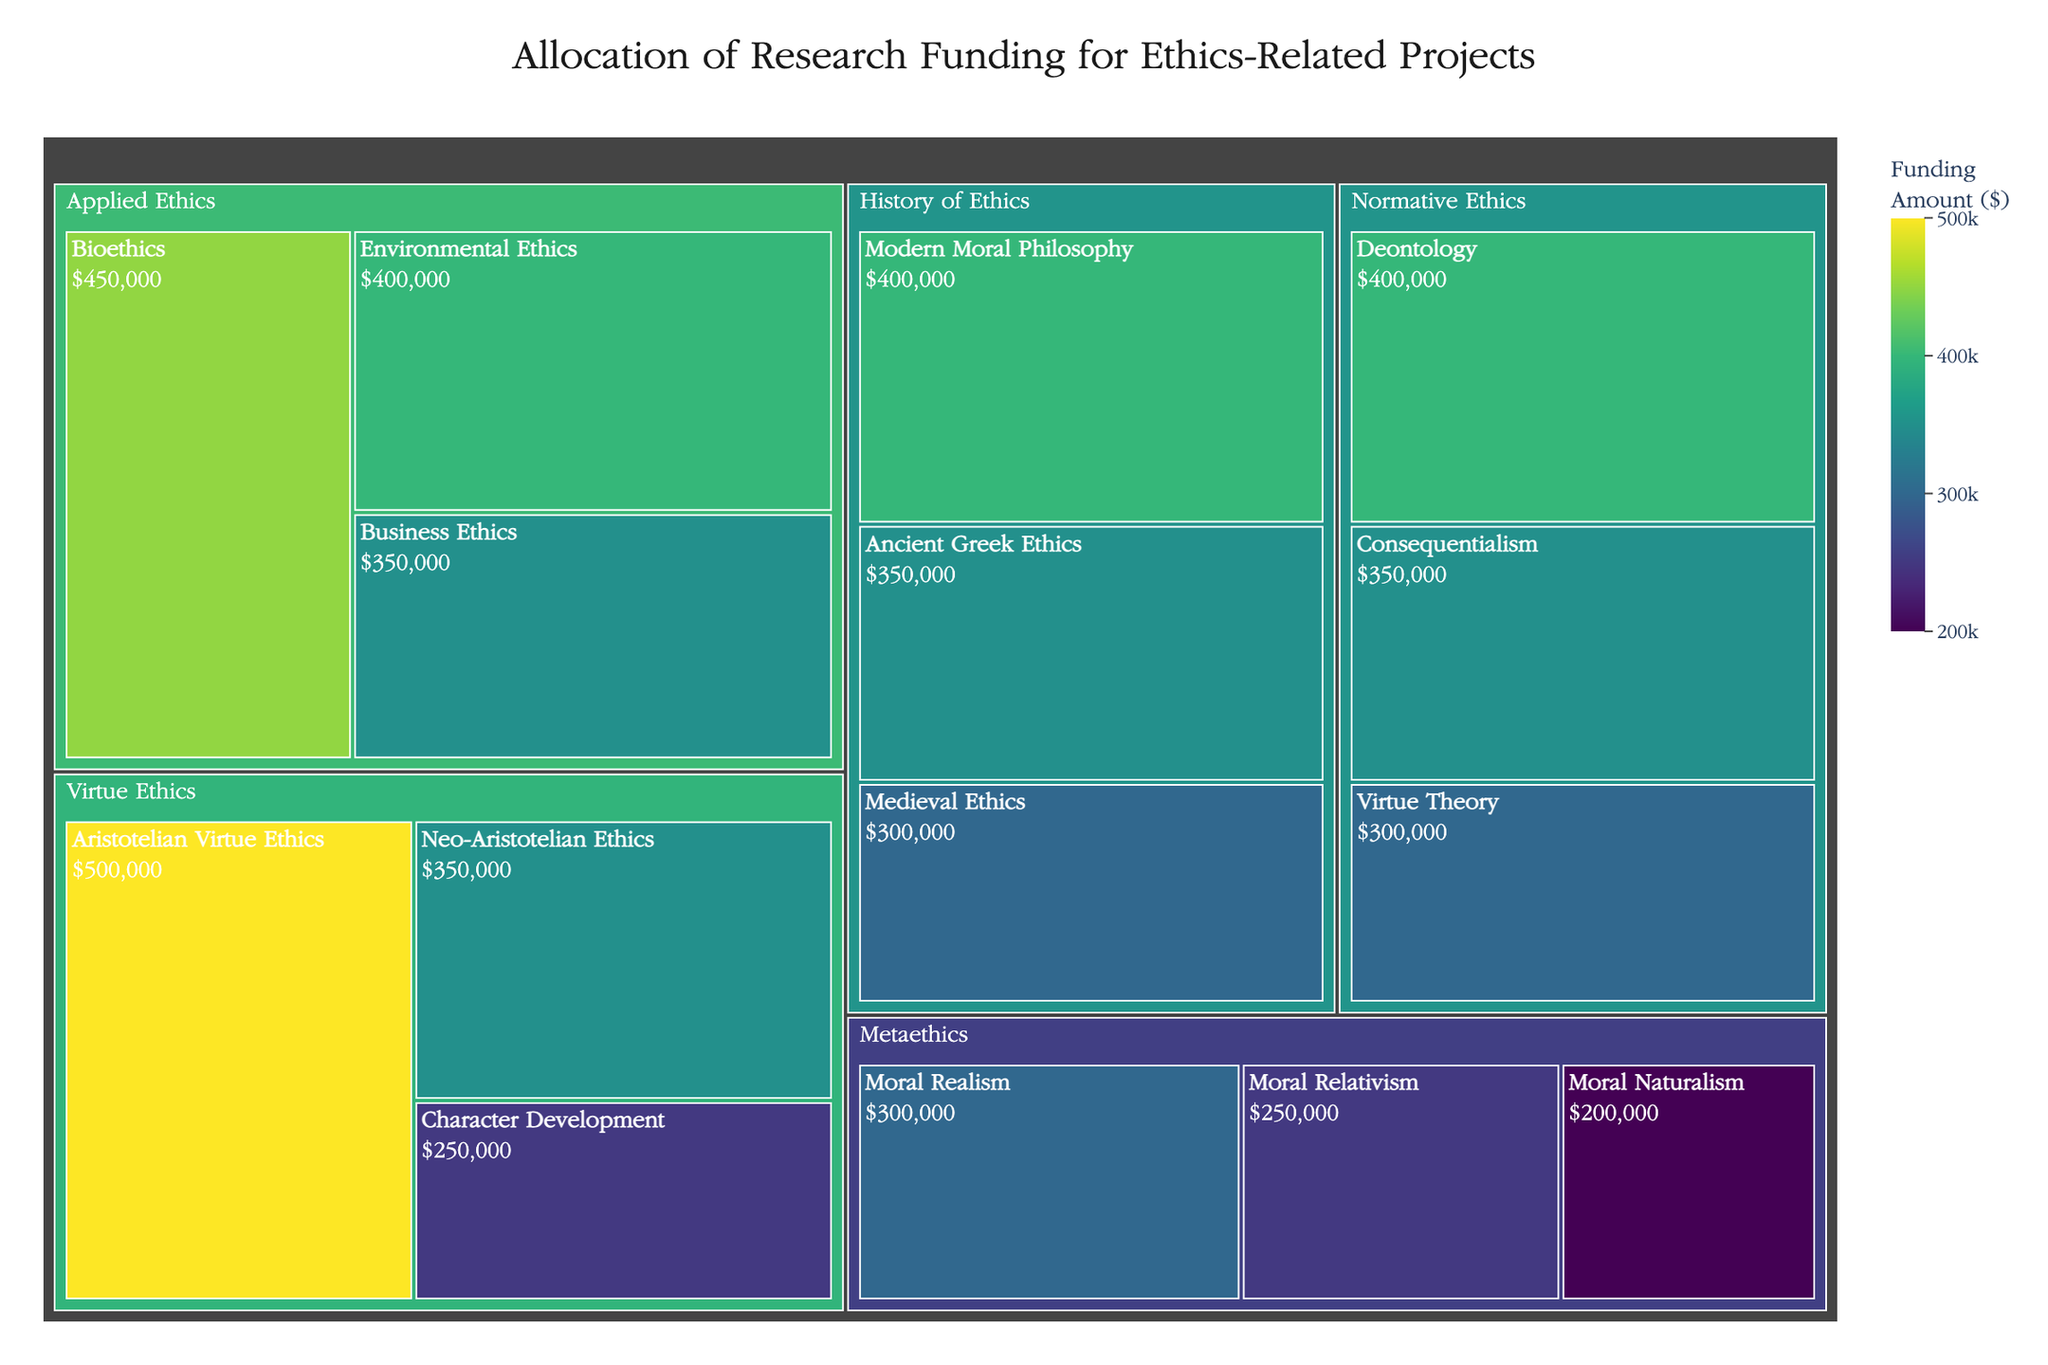What's the title of the treemap? The title is displayed at the top of the treemap in a larger and bold font. Based on this position and formatting, we can easily read and find the title of the treemap.
Answer: Allocation of Research Funding for Ethics-Related Projects Which category has the highest total funding? Observing the treemap, the category with the largest combined area represents the highest total funding. The 'Virtue Ethics' category is the largest, indicating it has the most combined funding.
Answer: Virtue Ethics What is the amount of funding allocated to Aristotelian Virtue Ethics? The subcategory 'Aristotelian Virtue Ethics' is labeled within its section. The funding amount is displayed within the section text and also highlighted when hovering over it.
Answer: $500,000 What is the total funding allocated to all Normative Ethics subcategories? Add the funding amounts of the three Normative Ethics subcategories: Deontology ($400,000), Consequentialism ($350,000), and Virtue Theory ($300,000). The total is $400,000 + $350,000 + $300,000.
Answer: $1,050,000 Which has more funding: Business Ethics or Character Development? Compare the funding amounts directly from the treemap. Business Ethics has $350,000, and Character Development has $250,000.
Answer: Business Ethics How does the funding for Ancient Greek Ethics compare to Modern Moral Philosophy? Look at the respective sections labeled 'Ancient Greek Ethics' and 'Modern Moral Philosophy'. Ancient Greek Ethics has $350,000, while Modern Moral Philosophy has $400,000. Thus, Modern Moral Philosophy has more funding.
Answer: Modern Moral Philosophy has more funding What is the average funding amount for Applied Ethics subcategories? First, find the funding amounts for the three Applied Ethics subcategories: Bioethics ($450,000), Environmental Ethics ($400,000), and Business Ethics ($350,000). Sum them up: $450,000 + $400,000 + $350,000 = $1,200,000. Divide by 3 to get the average: $1,200,000 / 3.
Answer: $400,000 List all subcategories under Metaethics and their corresponding funding amounts. Observe the sections under the Metaethics category: Moral Realism ($300,000), Moral Relativism ($250,000), Moral Naturalism ($200,000).
Answer: Moral Realism: $300,000, Moral Relativism: $250,000, Moral Naturalism: $200,000 Which category has the smallest total funding, and how much is it? Identify the smallest category by area within the treemap. Metaethics is the smallest, and summing the amount of its subcategories: $300,000 + $250,000 + $200,000 = $750,000 reveals its total funding.
Answer: Metaethics, $750,000 